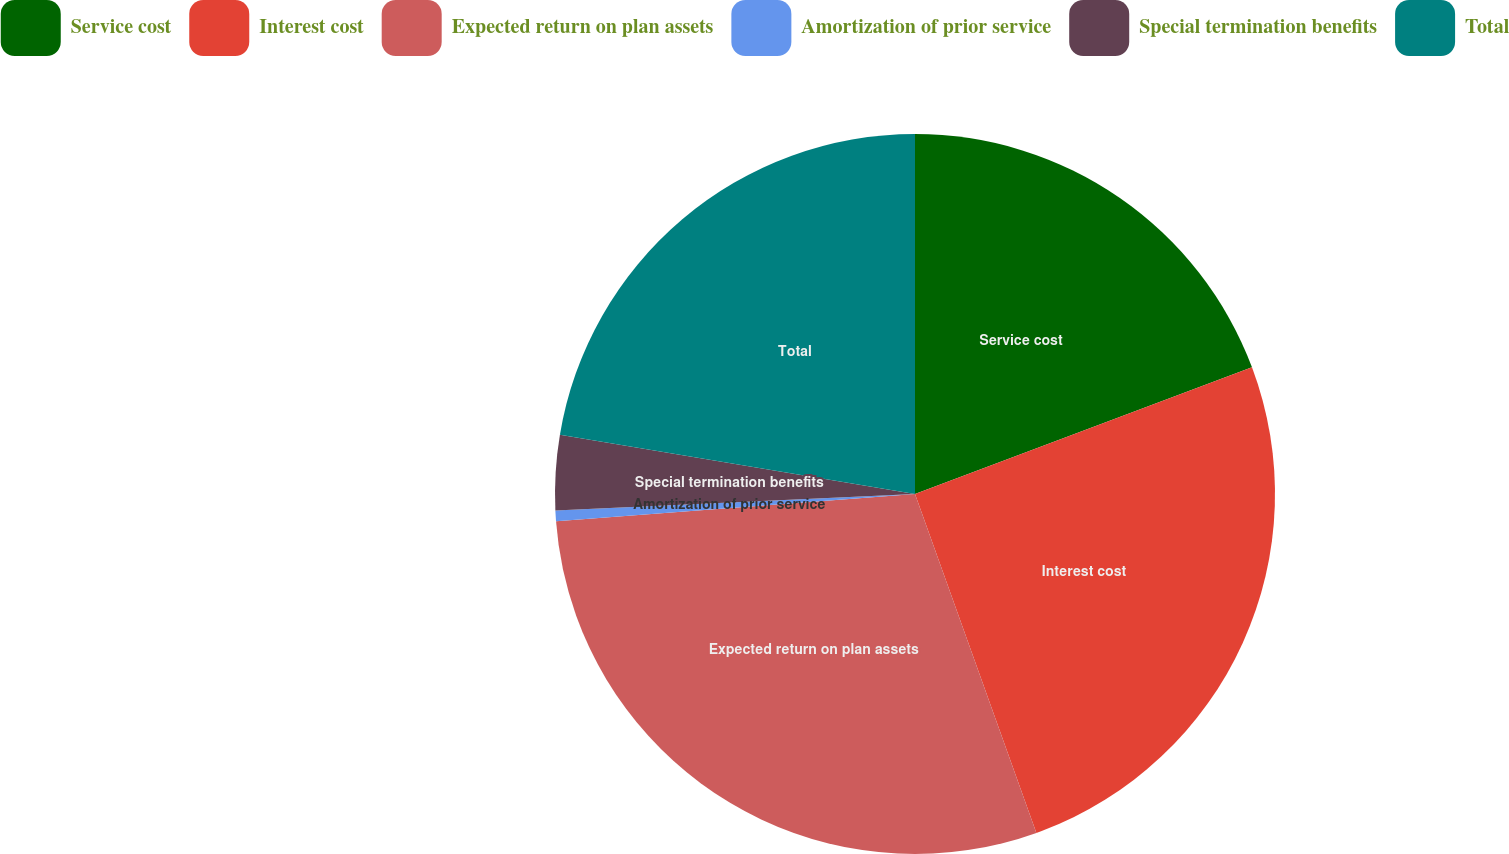Convert chart to OTSL. <chart><loc_0><loc_0><loc_500><loc_500><pie_chart><fcel>Service cost<fcel>Interest cost<fcel>Expected return on plan assets<fcel>Amortization of prior service<fcel>Special termination benefits<fcel>Total<nl><fcel>19.28%<fcel>25.25%<fcel>29.27%<fcel>0.48%<fcel>3.36%<fcel>22.37%<nl></chart> 